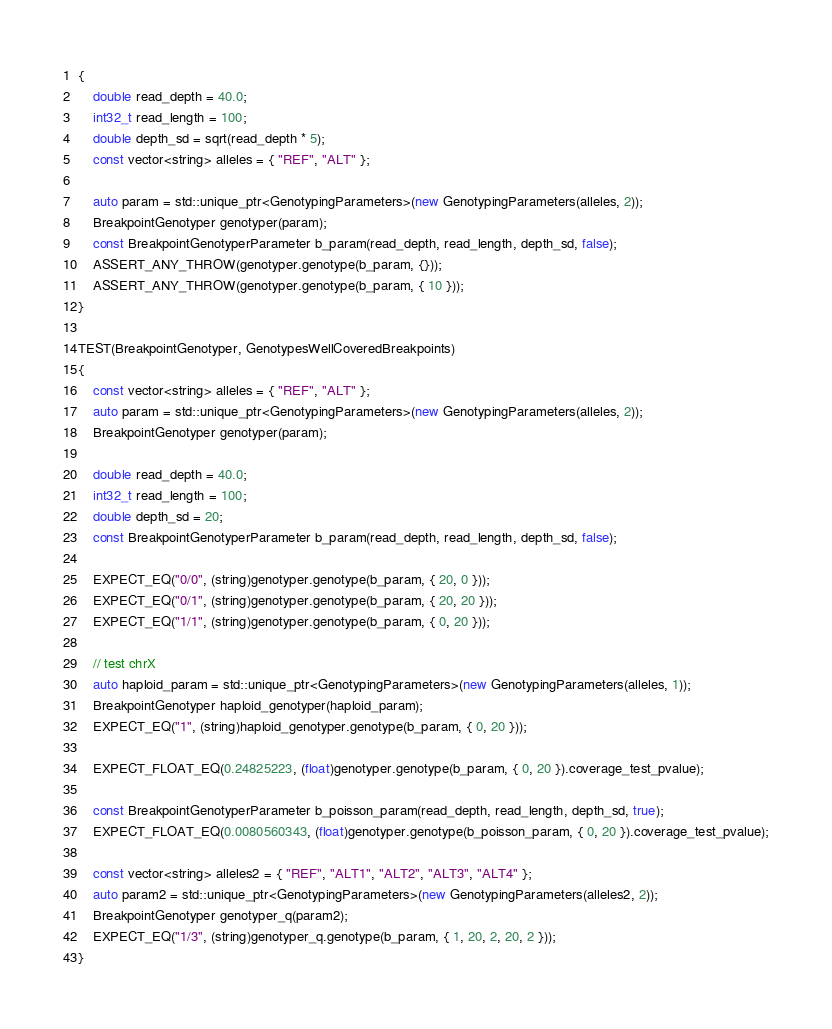Convert code to text. <code><loc_0><loc_0><loc_500><loc_500><_C++_>{
    double read_depth = 40.0;
    int32_t read_length = 100;
    double depth_sd = sqrt(read_depth * 5);
    const vector<string> alleles = { "REF", "ALT" };

    auto param = std::unique_ptr<GenotypingParameters>(new GenotypingParameters(alleles, 2));
    BreakpointGenotyper genotyper(param);
    const BreakpointGenotyperParameter b_param(read_depth, read_length, depth_sd, false);
    ASSERT_ANY_THROW(genotyper.genotype(b_param, {}));
    ASSERT_ANY_THROW(genotyper.genotype(b_param, { 10 }));
}

TEST(BreakpointGenotyper, GenotypesWellCoveredBreakpoints)
{
    const vector<string> alleles = { "REF", "ALT" };
    auto param = std::unique_ptr<GenotypingParameters>(new GenotypingParameters(alleles, 2));
    BreakpointGenotyper genotyper(param);

    double read_depth = 40.0;
    int32_t read_length = 100;
    double depth_sd = 20;
    const BreakpointGenotyperParameter b_param(read_depth, read_length, depth_sd, false);

    EXPECT_EQ("0/0", (string)genotyper.genotype(b_param, { 20, 0 }));
    EXPECT_EQ("0/1", (string)genotyper.genotype(b_param, { 20, 20 }));
    EXPECT_EQ("1/1", (string)genotyper.genotype(b_param, { 0, 20 }));

    // test chrX
    auto haploid_param = std::unique_ptr<GenotypingParameters>(new GenotypingParameters(alleles, 1));
    BreakpointGenotyper haploid_genotyper(haploid_param);
    EXPECT_EQ("1", (string)haploid_genotyper.genotype(b_param, { 0, 20 }));

    EXPECT_FLOAT_EQ(0.24825223, (float)genotyper.genotype(b_param, { 0, 20 }).coverage_test_pvalue);

    const BreakpointGenotyperParameter b_poisson_param(read_depth, read_length, depth_sd, true);
    EXPECT_FLOAT_EQ(0.0080560343, (float)genotyper.genotype(b_poisson_param, { 0, 20 }).coverage_test_pvalue);

    const vector<string> alleles2 = { "REF", "ALT1", "ALT2", "ALT3", "ALT4" };
    auto param2 = std::unique_ptr<GenotypingParameters>(new GenotypingParameters(alleles2, 2));
    BreakpointGenotyper genotyper_q(param2);
    EXPECT_EQ("1/3", (string)genotyper_q.genotype(b_param, { 1, 20, 2, 20, 2 }));
}</code> 